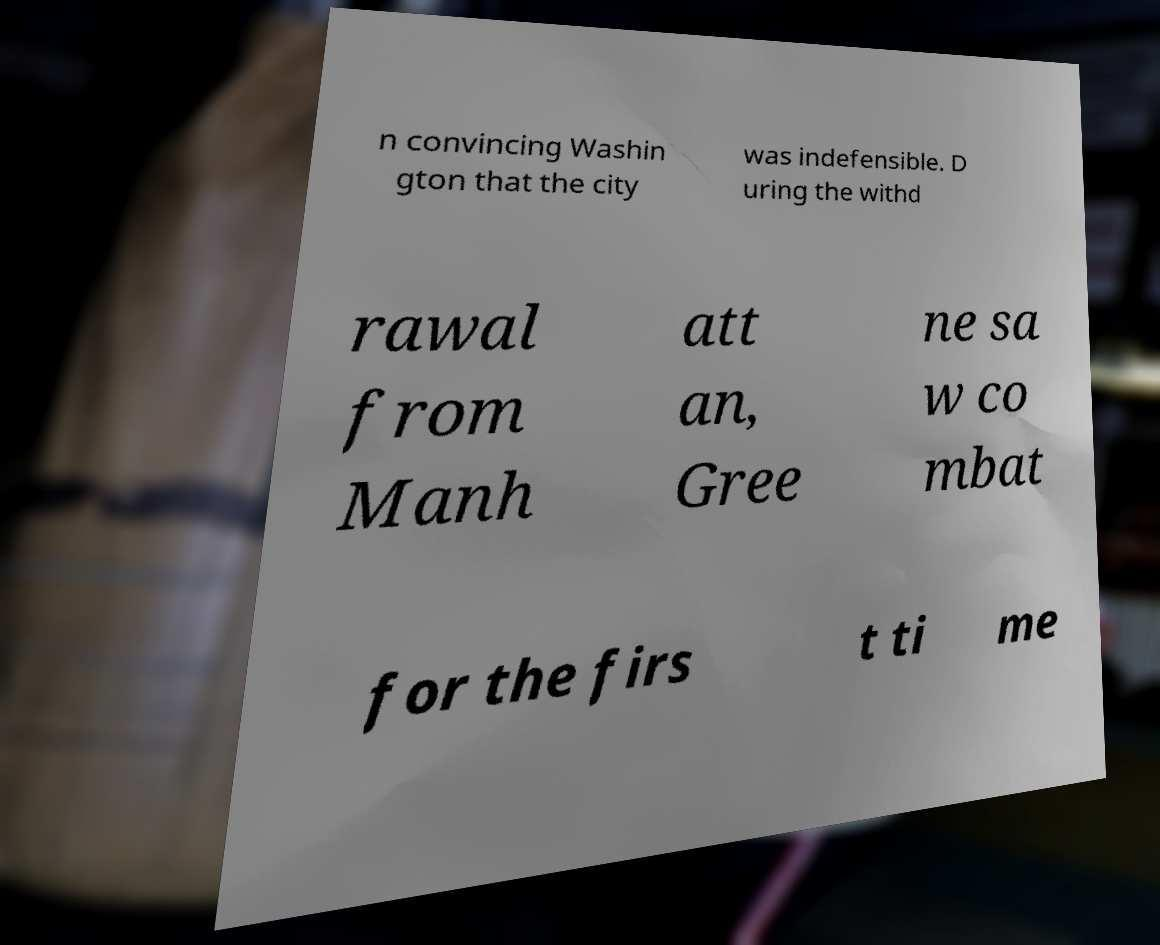Could you extract and type out the text from this image? n convincing Washin gton that the city was indefensible. D uring the withd rawal from Manh att an, Gree ne sa w co mbat for the firs t ti me 